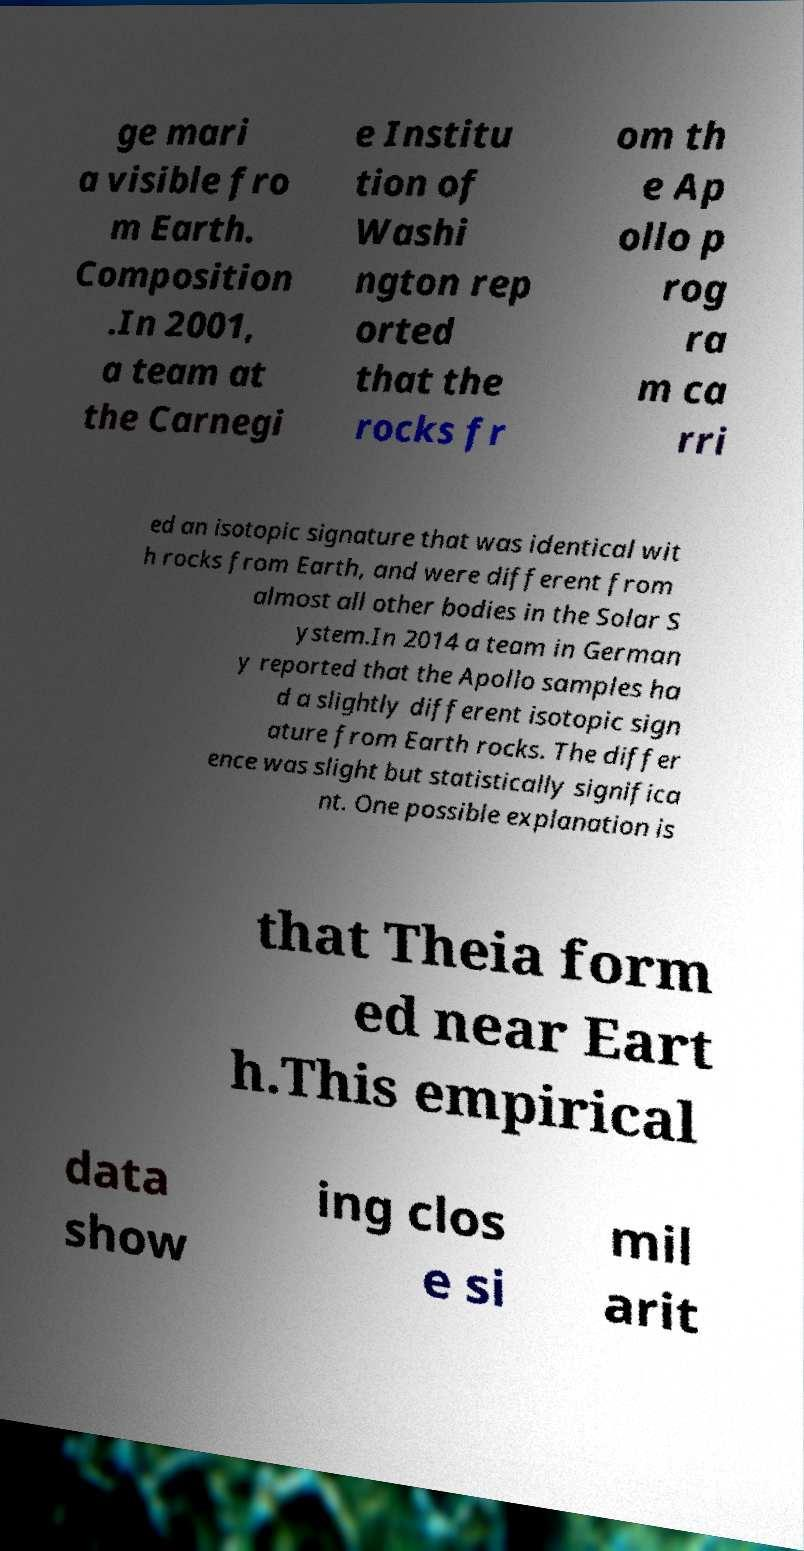Could you assist in decoding the text presented in this image and type it out clearly? ge mari a visible fro m Earth. Composition .In 2001, a team at the Carnegi e Institu tion of Washi ngton rep orted that the rocks fr om th e Ap ollo p rog ra m ca rri ed an isotopic signature that was identical wit h rocks from Earth, and were different from almost all other bodies in the Solar S ystem.In 2014 a team in German y reported that the Apollo samples ha d a slightly different isotopic sign ature from Earth rocks. The differ ence was slight but statistically significa nt. One possible explanation is that Theia form ed near Eart h.This empirical data show ing clos e si mil arit 